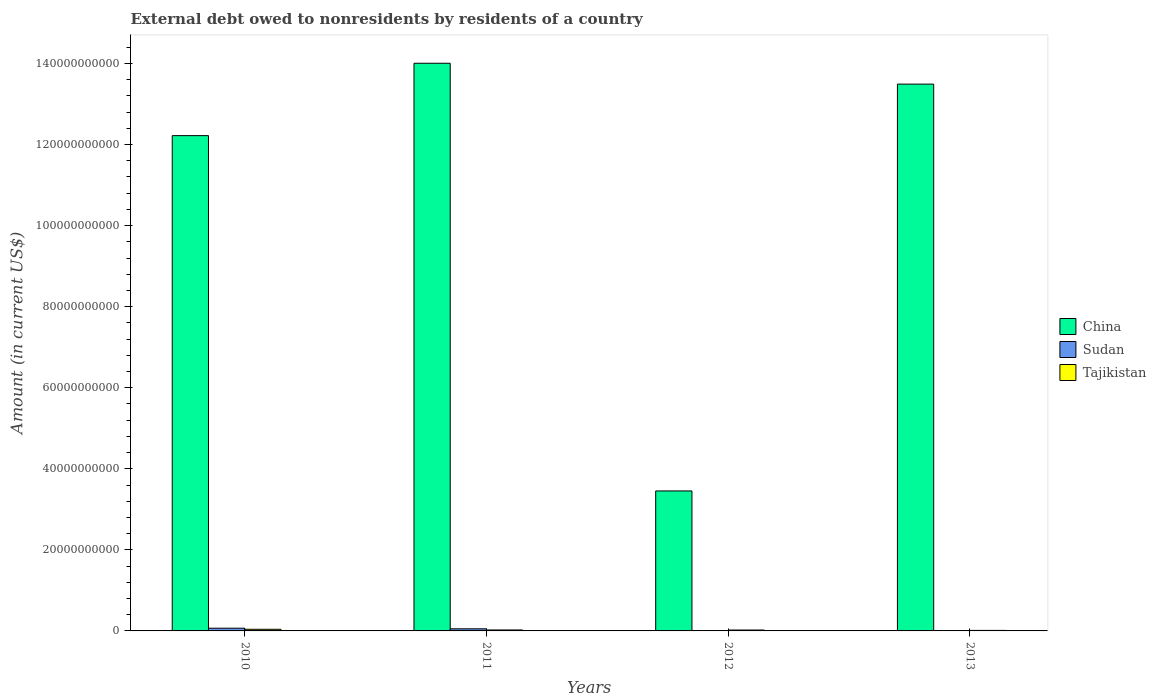How many different coloured bars are there?
Ensure brevity in your answer.  3. How many groups of bars are there?
Keep it short and to the point. 4. Are the number of bars on each tick of the X-axis equal?
Ensure brevity in your answer.  No. Across all years, what is the maximum external debt owed by residents in Tajikistan?
Give a very brief answer. 4.01e+08. Across all years, what is the minimum external debt owed by residents in Tajikistan?
Your answer should be very brief. 1.28e+08. In which year was the external debt owed by residents in China maximum?
Offer a very short reply. 2011. What is the total external debt owed by residents in China in the graph?
Make the answer very short. 4.32e+11. What is the difference between the external debt owed by residents in Tajikistan in 2011 and that in 2012?
Offer a terse response. 1.58e+07. What is the difference between the external debt owed by residents in Sudan in 2010 and the external debt owed by residents in Tajikistan in 2013?
Give a very brief answer. 5.41e+08. What is the average external debt owed by residents in Tajikistan per year?
Your answer should be very brief. 2.47e+08. In the year 2010, what is the difference between the external debt owed by residents in Sudan and external debt owed by residents in Tajikistan?
Ensure brevity in your answer.  2.68e+08. In how many years, is the external debt owed by residents in Tajikistan greater than 28000000000 US$?
Make the answer very short. 0. What is the ratio of the external debt owed by residents in China in 2010 to that in 2012?
Keep it short and to the point. 3.54. Is the external debt owed by residents in China in 2010 less than that in 2013?
Offer a very short reply. Yes. Is the difference between the external debt owed by residents in Sudan in 2010 and 2011 greater than the difference between the external debt owed by residents in Tajikistan in 2010 and 2011?
Provide a short and direct response. No. What is the difference between the highest and the second highest external debt owed by residents in Sudan?
Give a very brief answer. 1.45e+08. What is the difference between the highest and the lowest external debt owed by residents in Tajikistan?
Your answer should be very brief. 2.73e+08. Is it the case that in every year, the sum of the external debt owed by residents in Sudan and external debt owed by residents in Tajikistan is greater than the external debt owed by residents in China?
Offer a very short reply. No. Are the values on the major ticks of Y-axis written in scientific E-notation?
Your response must be concise. No. Does the graph contain grids?
Your response must be concise. No. How many legend labels are there?
Your answer should be compact. 3. What is the title of the graph?
Provide a succinct answer. External debt owed to nonresidents by residents of a country. Does "Guyana" appear as one of the legend labels in the graph?
Your answer should be very brief. No. What is the Amount (in current US$) in China in 2010?
Offer a terse response. 1.22e+11. What is the Amount (in current US$) of Sudan in 2010?
Make the answer very short. 6.69e+08. What is the Amount (in current US$) in Tajikistan in 2010?
Provide a short and direct response. 4.01e+08. What is the Amount (in current US$) of China in 2011?
Your answer should be very brief. 1.40e+11. What is the Amount (in current US$) of Sudan in 2011?
Provide a succinct answer. 5.24e+08. What is the Amount (in current US$) in Tajikistan in 2011?
Offer a very short reply. 2.38e+08. What is the Amount (in current US$) in China in 2012?
Your response must be concise. 3.45e+1. What is the Amount (in current US$) in Tajikistan in 2012?
Offer a very short reply. 2.22e+08. What is the Amount (in current US$) of China in 2013?
Offer a terse response. 1.35e+11. What is the Amount (in current US$) in Sudan in 2013?
Your answer should be very brief. 8.99e+07. What is the Amount (in current US$) in Tajikistan in 2013?
Give a very brief answer. 1.28e+08. Across all years, what is the maximum Amount (in current US$) in China?
Your answer should be very brief. 1.40e+11. Across all years, what is the maximum Amount (in current US$) of Sudan?
Your answer should be very brief. 6.69e+08. Across all years, what is the maximum Amount (in current US$) of Tajikistan?
Offer a very short reply. 4.01e+08. Across all years, what is the minimum Amount (in current US$) of China?
Provide a short and direct response. 3.45e+1. Across all years, what is the minimum Amount (in current US$) of Tajikistan?
Offer a very short reply. 1.28e+08. What is the total Amount (in current US$) of China in the graph?
Provide a succinct answer. 4.32e+11. What is the total Amount (in current US$) of Sudan in the graph?
Offer a very short reply. 1.28e+09. What is the total Amount (in current US$) of Tajikistan in the graph?
Ensure brevity in your answer.  9.90e+08. What is the difference between the Amount (in current US$) in China in 2010 and that in 2011?
Give a very brief answer. -1.79e+1. What is the difference between the Amount (in current US$) in Sudan in 2010 and that in 2011?
Provide a succinct answer. 1.45e+08. What is the difference between the Amount (in current US$) in Tajikistan in 2010 and that in 2011?
Provide a succinct answer. 1.63e+08. What is the difference between the Amount (in current US$) of China in 2010 and that in 2012?
Your answer should be very brief. 8.77e+1. What is the difference between the Amount (in current US$) of Tajikistan in 2010 and that in 2012?
Keep it short and to the point. 1.79e+08. What is the difference between the Amount (in current US$) in China in 2010 and that in 2013?
Your answer should be compact. -1.27e+1. What is the difference between the Amount (in current US$) of Sudan in 2010 and that in 2013?
Provide a succinct answer. 5.79e+08. What is the difference between the Amount (in current US$) in Tajikistan in 2010 and that in 2013?
Provide a succinct answer. 2.73e+08. What is the difference between the Amount (in current US$) in China in 2011 and that in 2012?
Offer a very short reply. 1.06e+11. What is the difference between the Amount (in current US$) of Tajikistan in 2011 and that in 2012?
Give a very brief answer. 1.58e+07. What is the difference between the Amount (in current US$) of China in 2011 and that in 2013?
Ensure brevity in your answer.  5.15e+09. What is the difference between the Amount (in current US$) in Sudan in 2011 and that in 2013?
Keep it short and to the point. 4.34e+08. What is the difference between the Amount (in current US$) of Tajikistan in 2011 and that in 2013?
Make the answer very short. 1.10e+08. What is the difference between the Amount (in current US$) in China in 2012 and that in 2013?
Your answer should be compact. -1.00e+11. What is the difference between the Amount (in current US$) of Tajikistan in 2012 and that in 2013?
Provide a succinct answer. 9.43e+07. What is the difference between the Amount (in current US$) of China in 2010 and the Amount (in current US$) of Sudan in 2011?
Your answer should be compact. 1.22e+11. What is the difference between the Amount (in current US$) of China in 2010 and the Amount (in current US$) of Tajikistan in 2011?
Your answer should be very brief. 1.22e+11. What is the difference between the Amount (in current US$) of Sudan in 2010 and the Amount (in current US$) of Tajikistan in 2011?
Offer a terse response. 4.31e+08. What is the difference between the Amount (in current US$) in China in 2010 and the Amount (in current US$) in Tajikistan in 2012?
Your answer should be very brief. 1.22e+11. What is the difference between the Amount (in current US$) in Sudan in 2010 and the Amount (in current US$) in Tajikistan in 2012?
Ensure brevity in your answer.  4.46e+08. What is the difference between the Amount (in current US$) of China in 2010 and the Amount (in current US$) of Sudan in 2013?
Your answer should be compact. 1.22e+11. What is the difference between the Amount (in current US$) in China in 2010 and the Amount (in current US$) in Tajikistan in 2013?
Offer a very short reply. 1.22e+11. What is the difference between the Amount (in current US$) in Sudan in 2010 and the Amount (in current US$) in Tajikistan in 2013?
Provide a succinct answer. 5.41e+08. What is the difference between the Amount (in current US$) of China in 2011 and the Amount (in current US$) of Tajikistan in 2012?
Provide a short and direct response. 1.40e+11. What is the difference between the Amount (in current US$) of Sudan in 2011 and the Amount (in current US$) of Tajikistan in 2012?
Provide a succinct answer. 3.01e+08. What is the difference between the Amount (in current US$) of China in 2011 and the Amount (in current US$) of Sudan in 2013?
Offer a very short reply. 1.40e+11. What is the difference between the Amount (in current US$) of China in 2011 and the Amount (in current US$) of Tajikistan in 2013?
Offer a terse response. 1.40e+11. What is the difference between the Amount (in current US$) of Sudan in 2011 and the Amount (in current US$) of Tajikistan in 2013?
Offer a terse response. 3.95e+08. What is the difference between the Amount (in current US$) of China in 2012 and the Amount (in current US$) of Sudan in 2013?
Ensure brevity in your answer.  3.44e+1. What is the difference between the Amount (in current US$) in China in 2012 and the Amount (in current US$) in Tajikistan in 2013?
Your answer should be very brief. 3.44e+1. What is the average Amount (in current US$) in China per year?
Provide a short and direct response. 1.08e+11. What is the average Amount (in current US$) of Sudan per year?
Your response must be concise. 3.21e+08. What is the average Amount (in current US$) in Tajikistan per year?
Ensure brevity in your answer.  2.47e+08. In the year 2010, what is the difference between the Amount (in current US$) of China and Amount (in current US$) of Sudan?
Give a very brief answer. 1.22e+11. In the year 2010, what is the difference between the Amount (in current US$) in China and Amount (in current US$) in Tajikistan?
Offer a very short reply. 1.22e+11. In the year 2010, what is the difference between the Amount (in current US$) of Sudan and Amount (in current US$) of Tajikistan?
Keep it short and to the point. 2.68e+08. In the year 2011, what is the difference between the Amount (in current US$) in China and Amount (in current US$) in Sudan?
Your answer should be compact. 1.40e+11. In the year 2011, what is the difference between the Amount (in current US$) in China and Amount (in current US$) in Tajikistan?
Ensure brevity in your answer.  1.40e+11. In the year 2011, what is the difference between the Amount (in current US$) in Sudan and Amount (in current US$) in Tajikistan?
Ensure brevity in your answer.  2.85e+08. In the year 2012, what is the difference between the Amount (in current US$) in China and Amount (in current US$) in Tajikistan?
Offer a terse response. 3.43e+1. In the year 2013, what is the difference between the Amount (in current US$) in China and Amount (in current US$) in Sudan?
Your answer should be compact. 1.35e+11. In the year 2013, what is the difference between the Amount (in current US$) of China and Amount (in current US$) of Tajikistan?
Your answer should be very brief. 1.35e+11. In the year 2013, what is the difference between the Amount (in current US$) of Sudan and Amount (in current US$) of Tajikistan?
Your answer should be very brief. -3.82e+07. What is the ratio of the Amount (in current US$) in China in 2010 to that in 2011?
Offer a terse response. 0.87. What is the ratio of the Amount (in current US$) of Sudan in 2010 to that in 2011?
Your answer should be very brief. 1.28. What is the ratio of the Amount (in current US$) of Tajikistan in 2010 to that in 2011?
Give a very brief answer. 1.68. What is the ratio of the Amount (in current US$) in China in 2010 to that in 2012?
Ensure brevity in your answer.  3.54. What is the ratio of the Amount (in current US$) in Tajikistan in 2010 to that in 2012?
Provide a succinct answer. 1.8. What is the ratio of the Amount (in current US$) in China in 2010 to that in 2013?
Ensure brevity in your answer.  0.91. What is the ratio of the Amount (in current US$) of Sudan in 2010 to that in 2013?
Your answer should be compact. 7.44. What is the ratio of the Amount (in current US$) in Tajikistan in 2010 to that in 2013?
Offer a very short reply. 3.13. What is the ratio of the Amount (in current US$) in China in 2011 to that in 2012?
Your answer should be compact. 4.06. What is the ratio of the Amount (in current US$) of Tajikistan in 2011 to that in 2012?
Offer a terse response. 1.07. What is the ratio of the Amount (in current US$) of China in 2011 to that in 2013?
Give a very brief answer. 1.04. What is the ratio of the Amount (in current US$) of Sudan in 2011 to that in 2013?
Make the answer very short. 5.82. What is the ratio of the Amount (in current US$) in Tajikistan in 2011 to that in 2013?
Your answer should be very brief. 1.86. What is the ratio of the Amount (in current US$) in China in 2012 to that in 2013?
Your answer should be compact. 0.26. What is the ratio of the Amount (in current US$) in Tajikistan in 2012 to that in 2013?
Make the answer very short. 1.74. What is the difference between the highest and the second highest Amount (in current US$) in China?
Your response must be concise. 5.15e+09. What is the difference between the highest and the second highest Amount (in current US$) in Sudan?
Give a very brief answer. 1.45e+08. What is the difference between the highest and the second highest Amount (in current US$) of Tajikistan?
Make the answer very short. 1.63e+08. What is the difference between the highest and the lowest Amount (in current US$) of China?
Your answer should be compact. 1.06e+11. What is the difference between the highest and the lowest Amount (in current US$) of Sudan?
Your answer should be very brief. 6.69e+08. What is the difference between the highest and the lowest Amount (in current US$) in Tajikistan?
Your answer should be compact. 2.73e+08. 